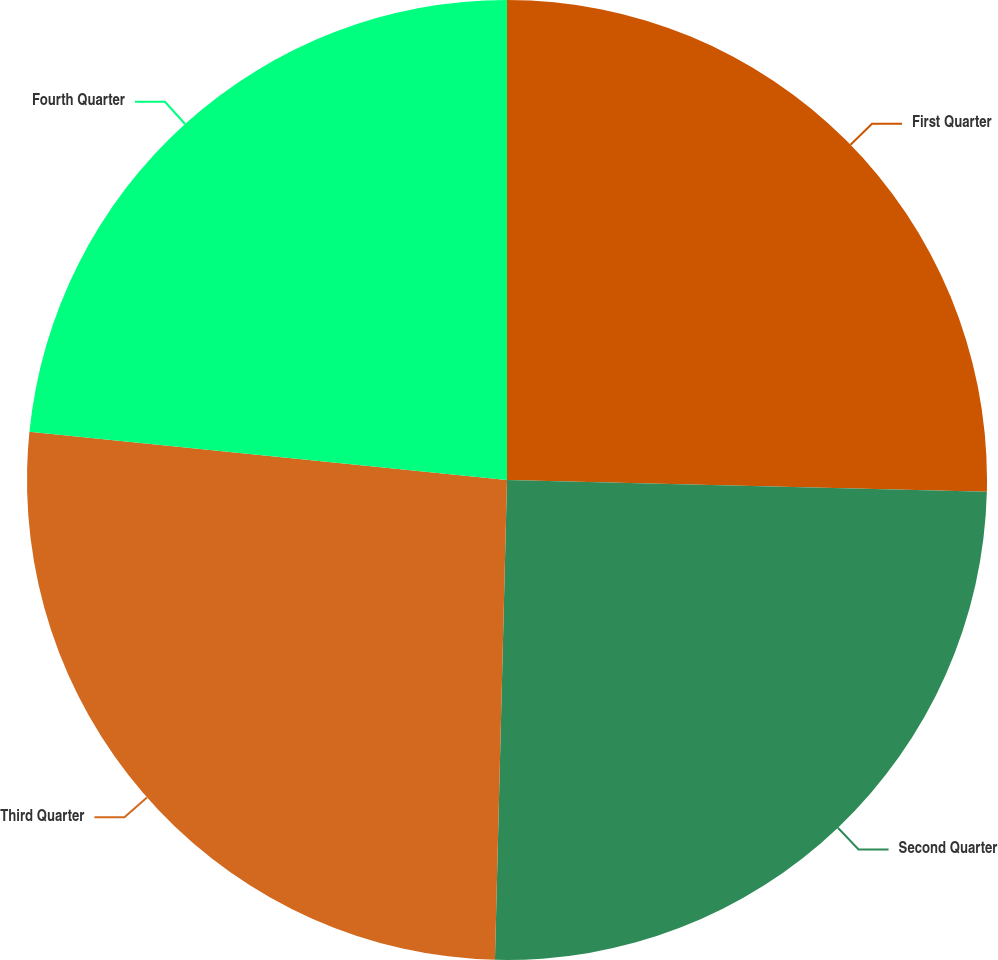Convert chart. <chart><loc_0><loc_0><loc_500><loc_500><pie_chart><fcel>First Quarter<fcel>Second Quarter<fcel>Third Quarter<fcel>Fourth Quarter<nl><fcel>25.39%<fcel>25.01%<fcel>26.2%<fcel>23.4%<nl></chart> 